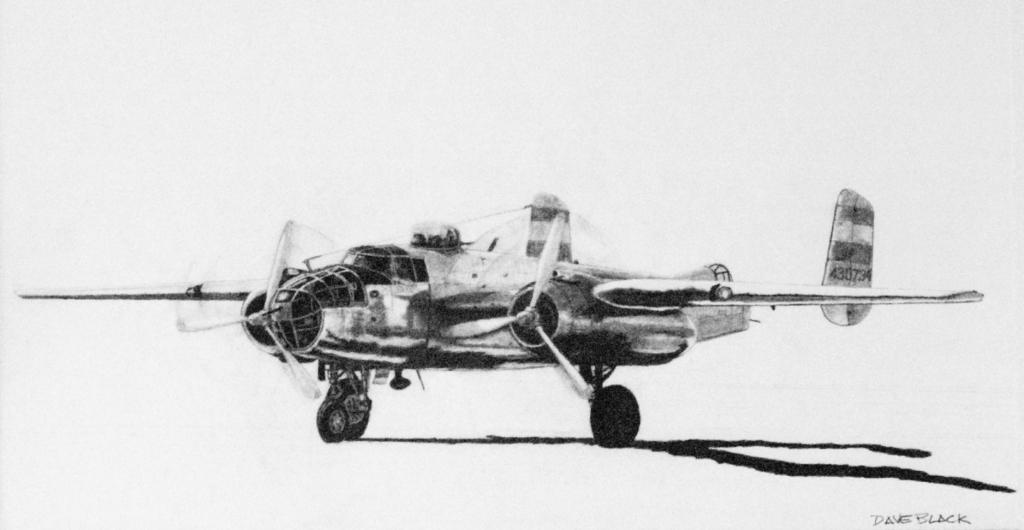What is the main subject of the picture? The main subject of the picture is a plane. Can you describe any additional details about the plane? Unfortunately, the provided facts do not mention any additional details about the plane. What is written in the right bottom corner of the image? There is text written in the right bottom corner of the image. What type of fang can be seen in the picture? There is no fang present in the image; it features a plane and text in the right bottom corner. Can you tell me who the partner of the person in the picture is? There is no person present in the image, only a plane and text in the right bottom corner. 